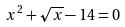<formula> <loc_0><loc_0><loc_500><loc_500>x ^ { 2 } + \sqrt { x } - 1 4 = 0</formula> 